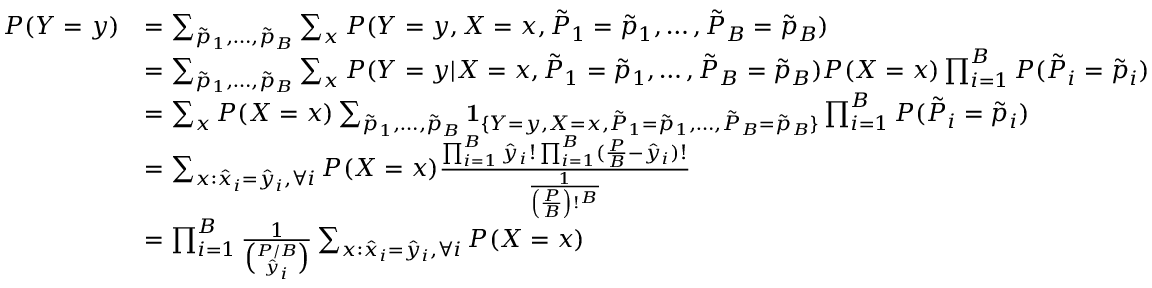<formula> <loc_0><loc_0><loc_500><loc_500>\begin{array} { r l } { P ( Y = y ) } & { = \sum _ { \tilde { p } _ { 1 } , \dots , \tilde { p } _ { B } } \sum _ { x } P ( Y = y , X = x , \tilde { P } _ { 1 } = \tilde { p } _ { 1 } , \dots , \tilde { P } _ { B } = \tilde { p } _ { B } ) } \\ & { = \sum _ { \tilde { p } _ { 1 } , \dots , \tilde { p } _ { B } } \sum _ { x } P ( Y = y | X = x , \tilde { P } _ { 1 } = \tilde { p } _ { 1 } , \dots , \tilde { P } _ { B } = \tilde { p } _ { B } ) P ( X = x ) \prod _ { i = 1 } ^ { B } P ( \tilde { P } _ { i } = \tilde { p } _ { i } ) } \\ & { = \sum _ { x } P ( X = x ) \sum _ { \tilde { p } _ { 1 } , \dots , \tilde { p } _ { B } } 1 _ { \{ Y = y , X = x , \tilde { P } _ { 1 } = \tilde { p } _ { 1 } , \dots , \tilde { P } _ { B } = \tilde { p } _ { B } \} } \prod _ { i = 1 } ^ { B } P ( \tilde { P } _ { i } = \tilde { p } _ { i } ) } \\ & { = \sum _ { x \colon \hat { x } _ { i } = \hat { y } _ { i } , \forall i } P ( X = x ) \frac { \prod _ { i = 1 } ^ { B } \hat { y } _ { i } ! \prod _ { i = 1 } ^ { B } ( \frac { P } { B } - \hat { y } _ { i } ) ! } { \frac { 1 } { \left ( \frac { P } { B } \right ) ! ^ { B } } } } \\ & { = \prod _ { i = 1 } ^ { B } \frac { 1 } { \binom { P / B } { \hat { y } _ { i } } } \sum _ { x \colon \hat { x } _ { i } = \hat { y } _ { i } , \forall i } P ( X = x ) } \end{array}</formula> 